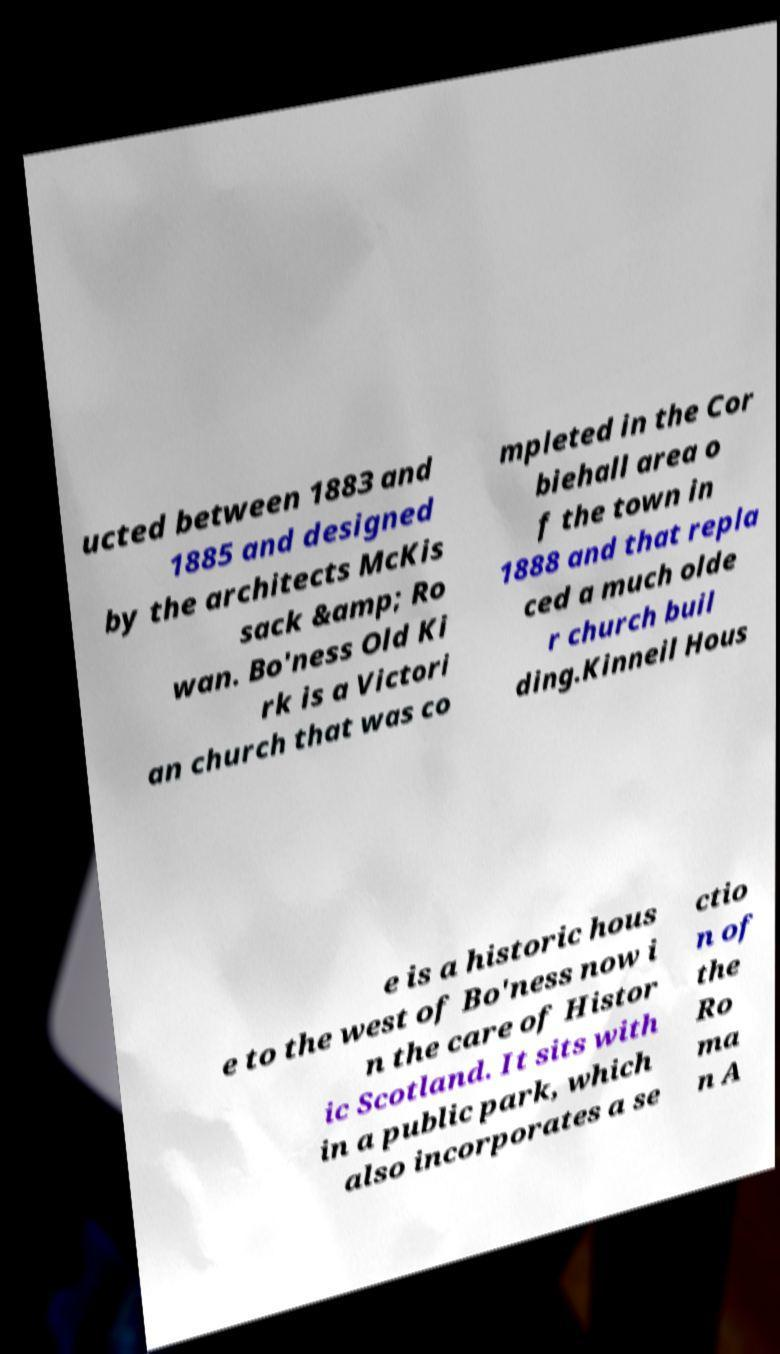Could you extract and type out the text from this image? ucted between 1883 and 1885 and designed by the architects McKis sack &amp; Ro wan. Bo'ness Old Ki rk is a Victori an church that was co mpleted in the Cor biehall area o f the town in 1888 and that repla ced a much olde r church buil ding.Kinneil Hous e is a historic hous e to the west of Bo'ness now i n the care of Histor ic Scotland. It sits with in a public park, which also incorporates a se ctio n of the Ro ma n A 